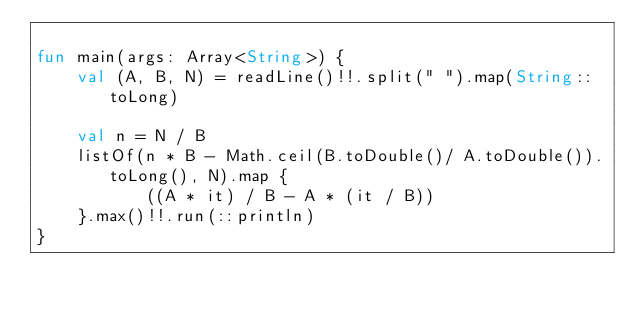Convert code to text. <code><loc_0><loc_0><loc_500><loc_500><_Kotlin_>
fun main(args: Array<String>) {
    val (A, B, N) = readLine()!!.split(" ").map(String::toLong)

    val n = N / B
    listOf(n * B - Math.ceil(B.toDouble()/ A.toDouble()).toLong(), N).map {
           ((A * it) / B - A * (it / B))
    }.max()!!.run(::println)
}</code> 